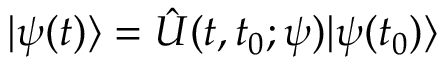Convert formula to latex. <formula><loc_0><loc_0><loc_500><loc_500>| \psi ( t ) \rangle = \hat { U } ( t , t _ { 0 } ; \psi ) | \psi ( t _ { 0 } ) \rangle</formula> 